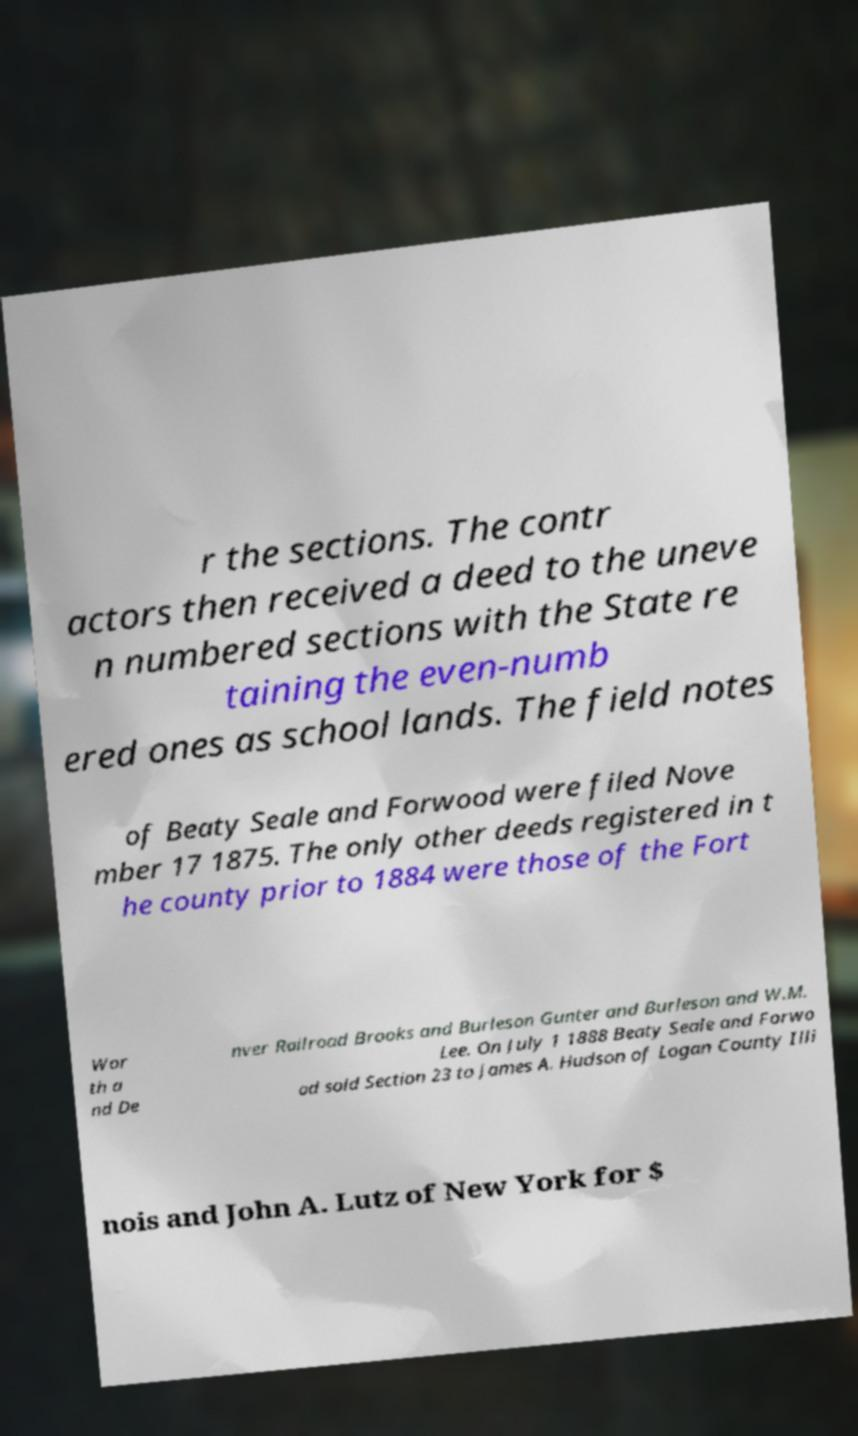I need the written content from this picture converted into text. Can you do that? r the sections. The contr actors then received a deed to the uneve n numbered sections with the State re taining the even-numb ered ones as school lands. The field notes of Beaty Seale and Forwood were filed Nove mber 17 1875. The only other deeds registered in t he county prior to 1884 were those of the Fort Wor th a nd De nver Railroad Brooks and Burleson Gunter and Burleson and W.M. Lee. On July 1 1888 Beaty Seale and Forwo od sold Section 23 to James A. Hudson of Logan County Illi nois and John A. Lutz of New York for $ 